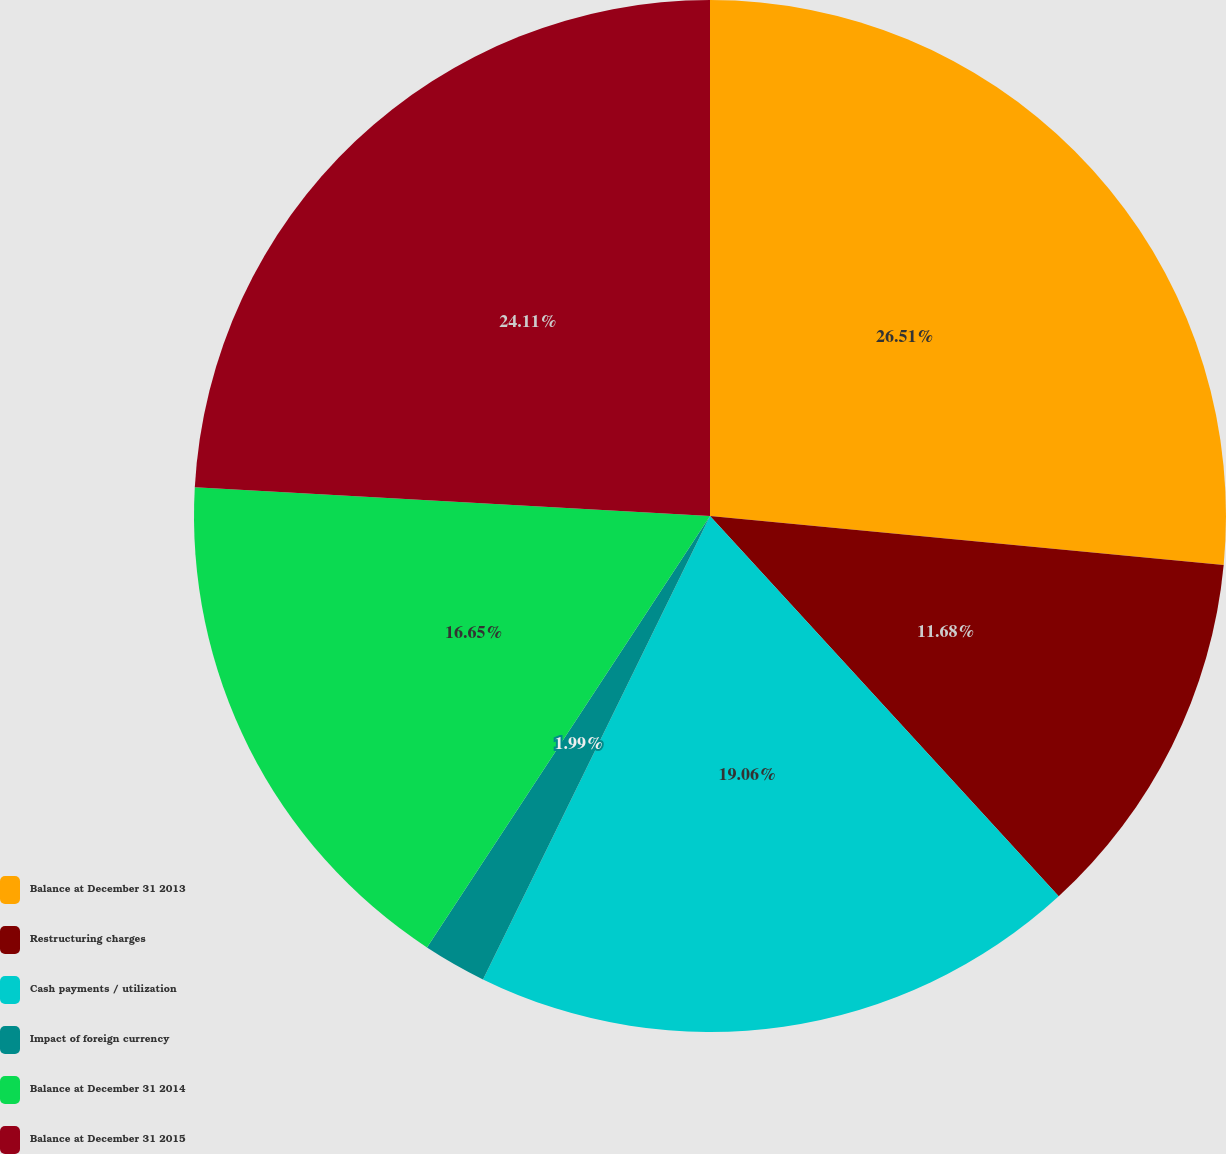Convert chart to OTSL. <chart><loc_0><loc_0><loc_500><loc_500><pie_chart><fcel>Balance at December 31 2013<fcel>Restructuring charges<fcel>Cash payments / utilization<fcel>Impact of foreign currency<fcel>Balance at December 31 2014<fcel>Balance at December 31 2015<nl><fcel>26.51%<fcel>11.68%<fcel>19.06%<fcel>1.99%<fcel>16.65%<fcel>24.11%<nl></chart> 